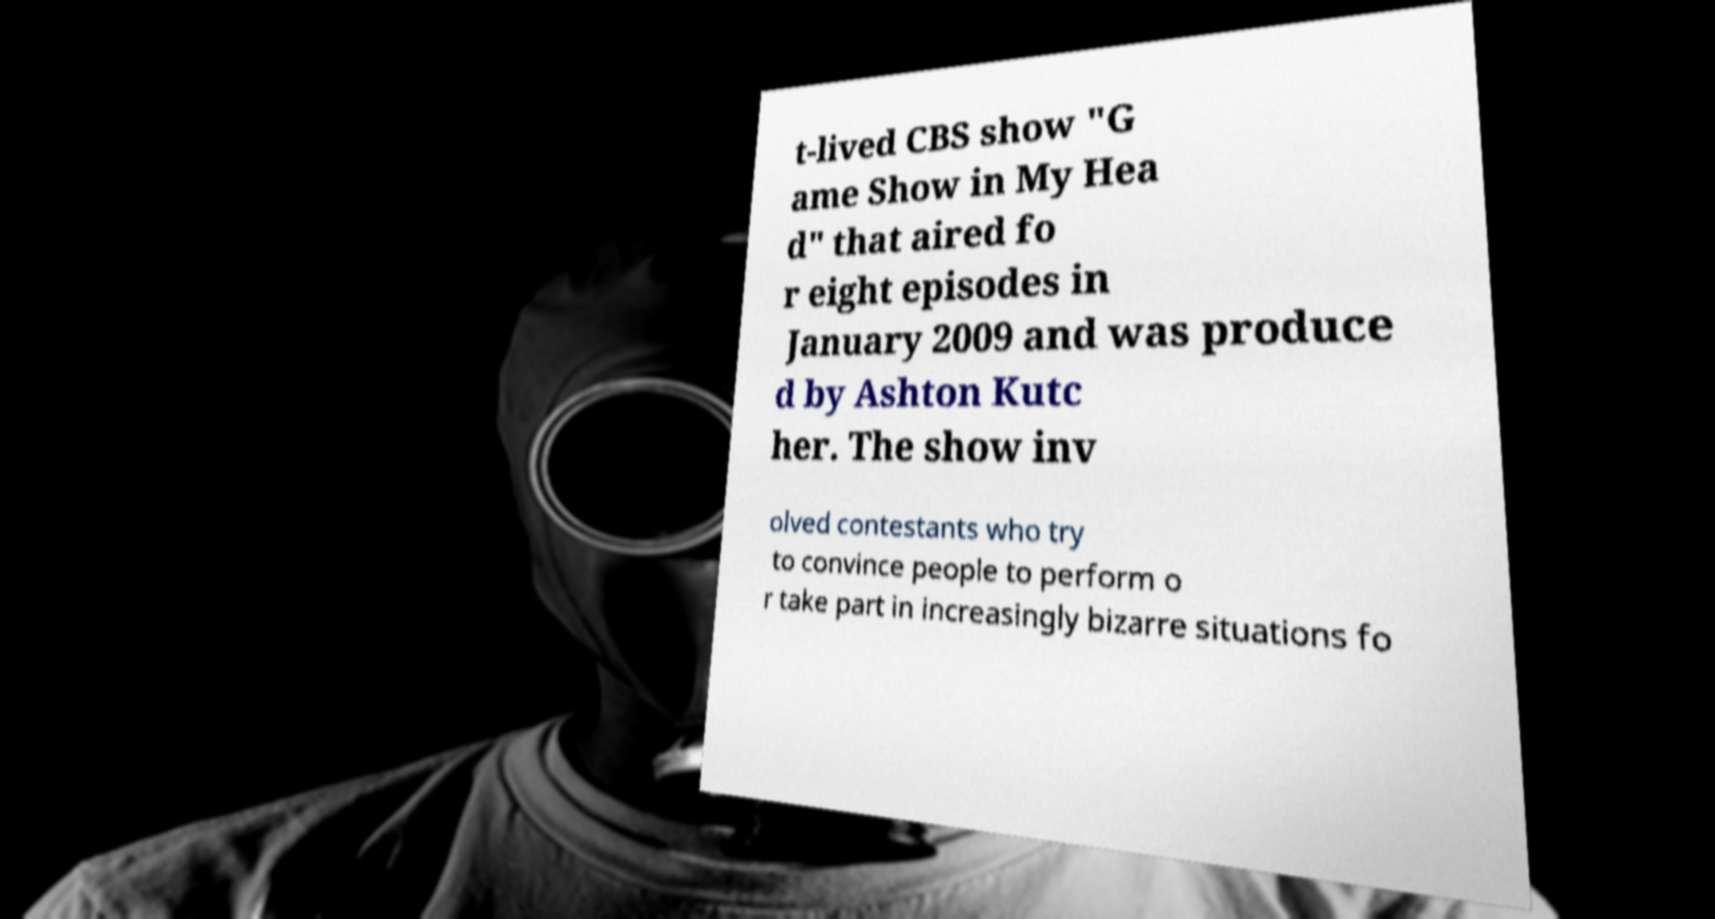I need the written content from this picture converted into text. Can you do that? t-lived CBS show "G ame Show in My Hea d" that aired fo r eight episodes in January 2009 and was produce d by Ashton Kutc her. The show inv olved contestants who try to convince people to perform o r take part in increasingly bizarre situations fo 